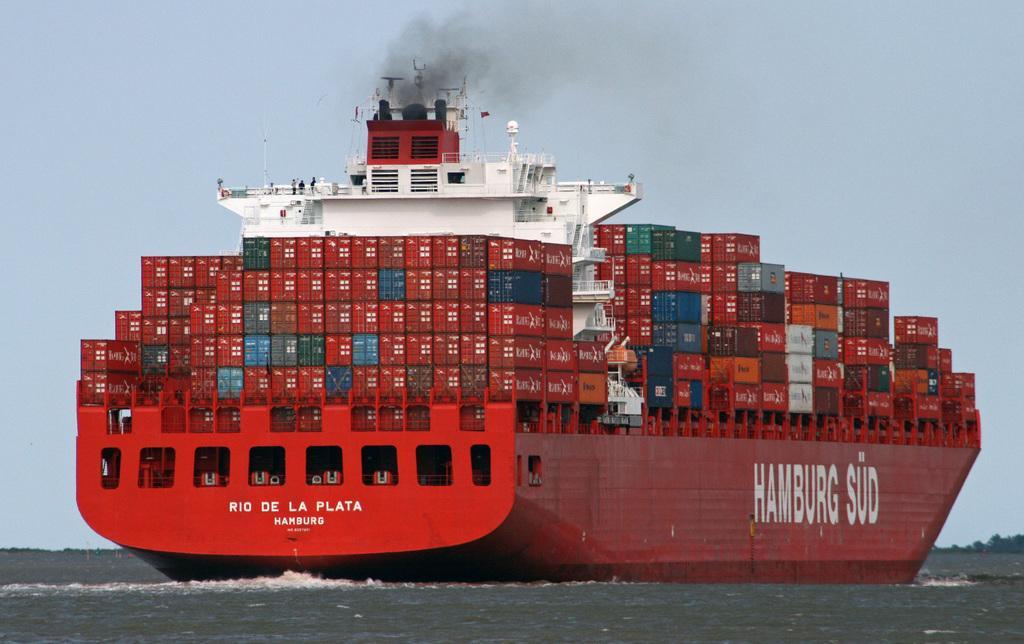Please provide a concise description of this image. As we can see in the image there is water and boat. On boat there are boxes and few people. At the top there is sky. 